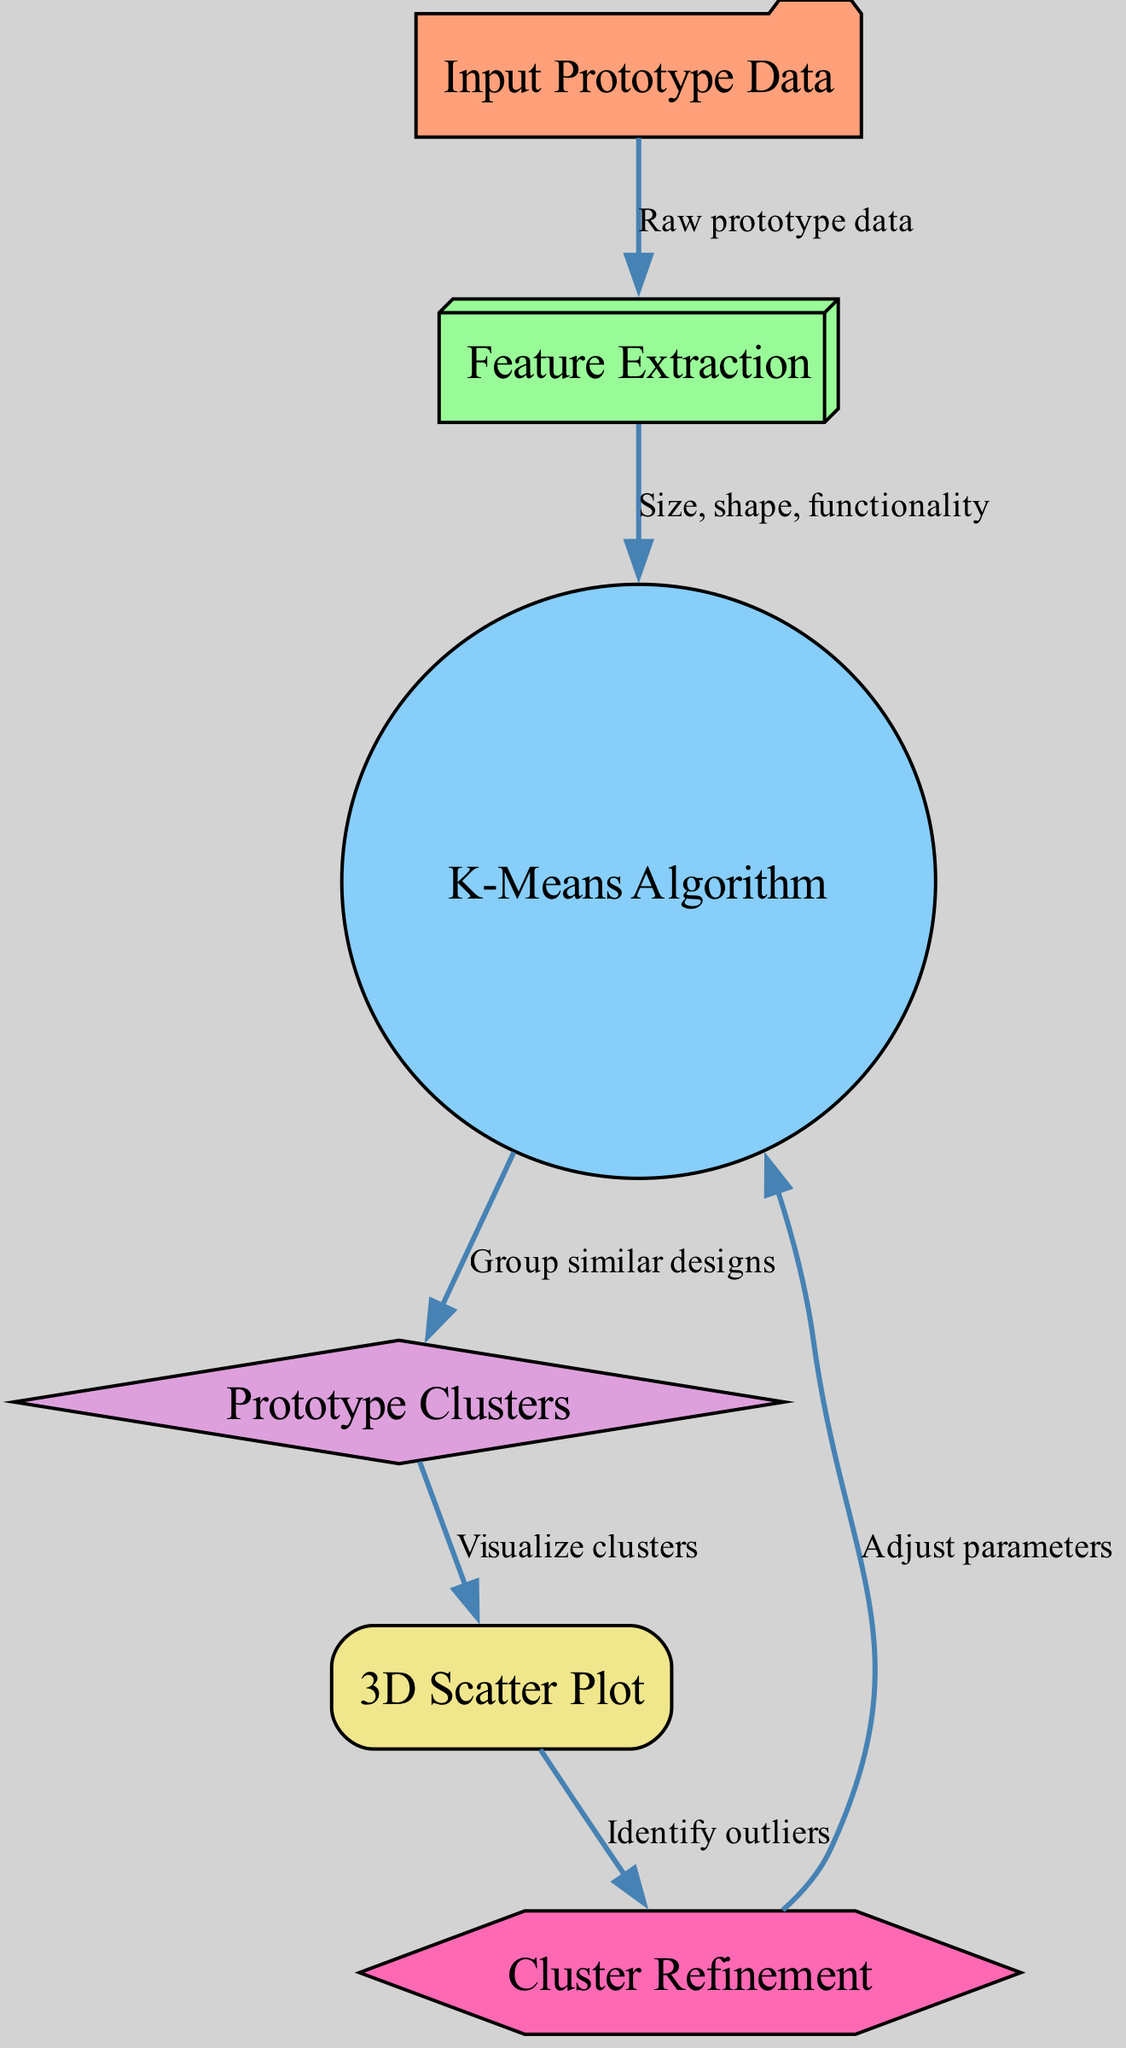What is the first step in the clustering algorithm? The first step in the diagram is labeled "Input Prototype Data." This node indicates that the process starts with gathering the raw prototype data necessary for features extraction.
Answer: Input Prototype Data How many main nodes are present in the diagram? By counting the nodes displayed in the diagram, we find that there are a total of six distinct nodes: Input Prototype Data, Feature Extraction, K-Means Algorithm, Prototype Clusters, 3D Scatter Plot, and Cluster Refinement.
Answer: Six Which node directly receives the output from the K-Means Algorithm? The K-Means Algorithm node is connected by an edge to the Prototype Clusters node, indicating that it outputs its results directly to this node for further processing.
Answer: Prototype Clusters What do the edges from the Cluster Refinement node indicate? The edges from Cluster Refinement indicate that this node connects back to the K-Means Algorithm. This shows the cyclic nature of the process where refinements may lead to adjustments in parameters and potentially trigger a new clustering iteration.
Answer: Adjust parameters What information flows to the K-Means Algorithm node? The K-Means Algorithm node receives the feature information, specifically the attributes like size, shape, and functionality, extracted from the Input Prototype Data in the previous step, thereby preparing the data for clustering.
Answer: Size, shape, functionality What type of visualization is used to present the Prototype Clusters? The visualization method utilized for presenting the Prototype Clusters is a 3D Scatter Plot, which enables the graphical representation of clusters formed through the algorithm.
Answer: 3D Scatter Plot 